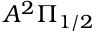<formula> <loc_0><loc_0><loc_500><loc_500>A ^ { 2 } \Pi _ { 1 / 2 }</formula> 